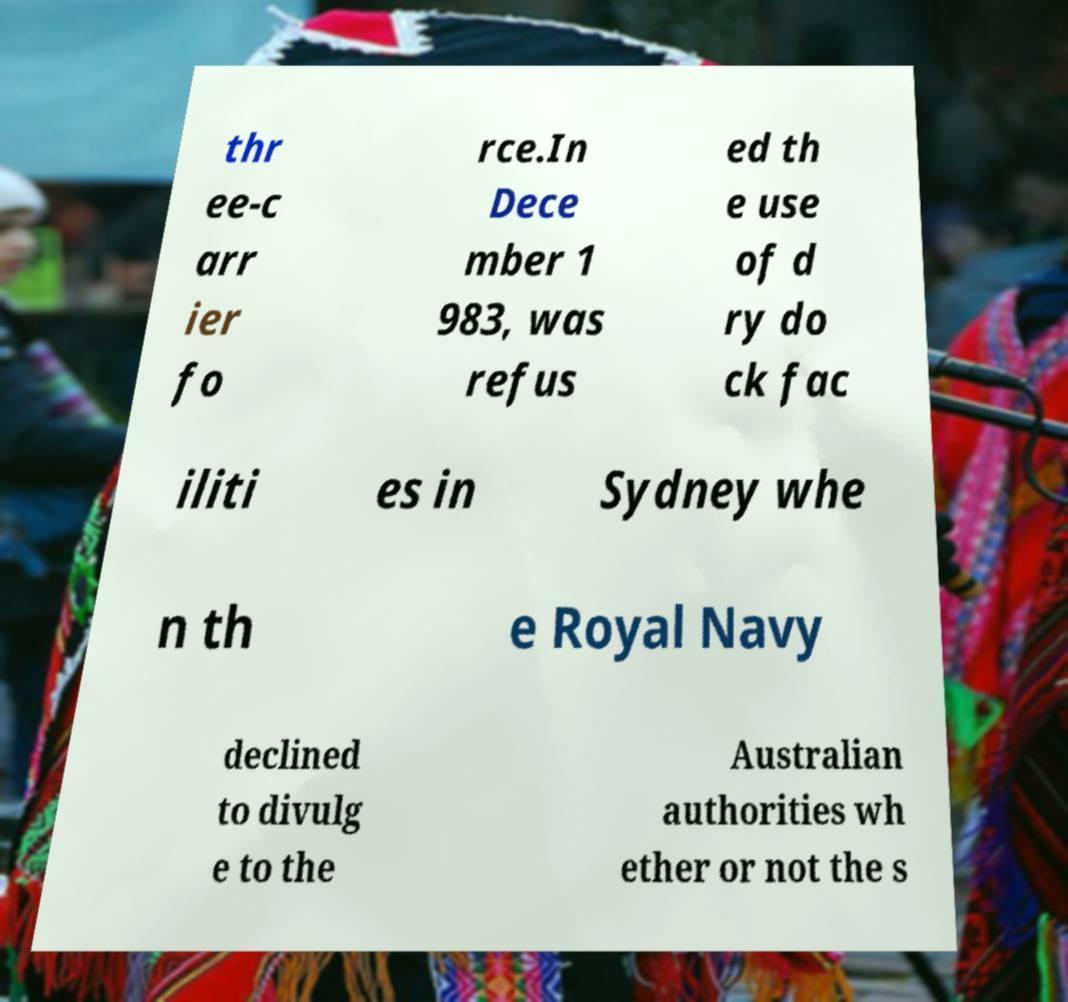Please read and relay the text visible in this image. What does it say? thr ee-c arr ier fo rce.In Dece mber 1 983, was refus ed th e use of d ry do ck fac iliti es in Sydney whe n th e Royal Navy declined to divulg e to the Australian authorities wh ether or not the s 